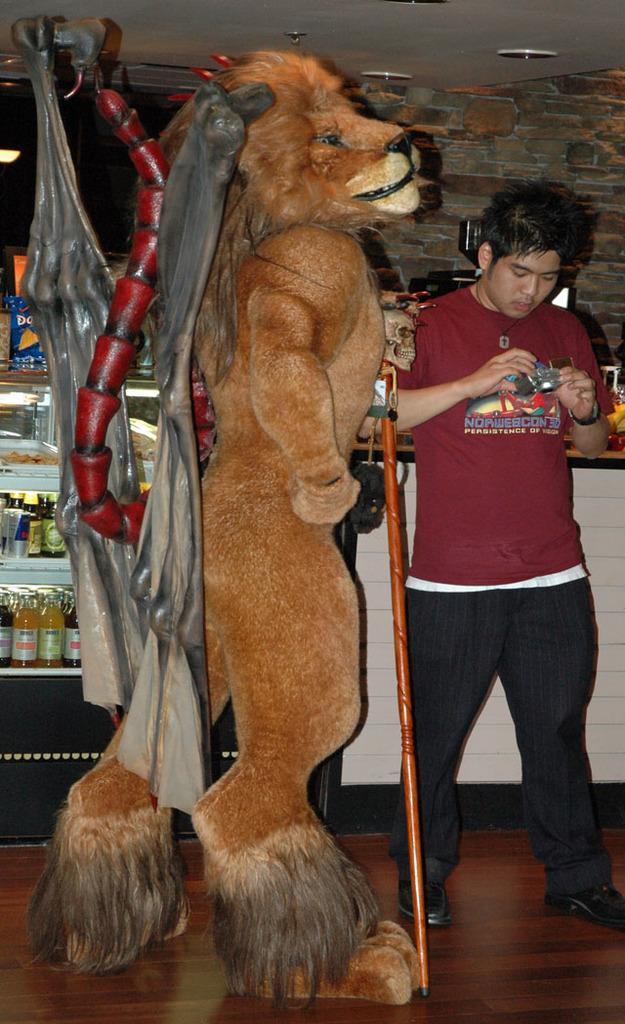Describe this image in one or two sentences. In this image I can see in the middle it is a doll in the shape of a lion. On the right side a man is standing, he wore t-shirt, trouser, shoes. On the left side there are glass bottles in the fridge. 